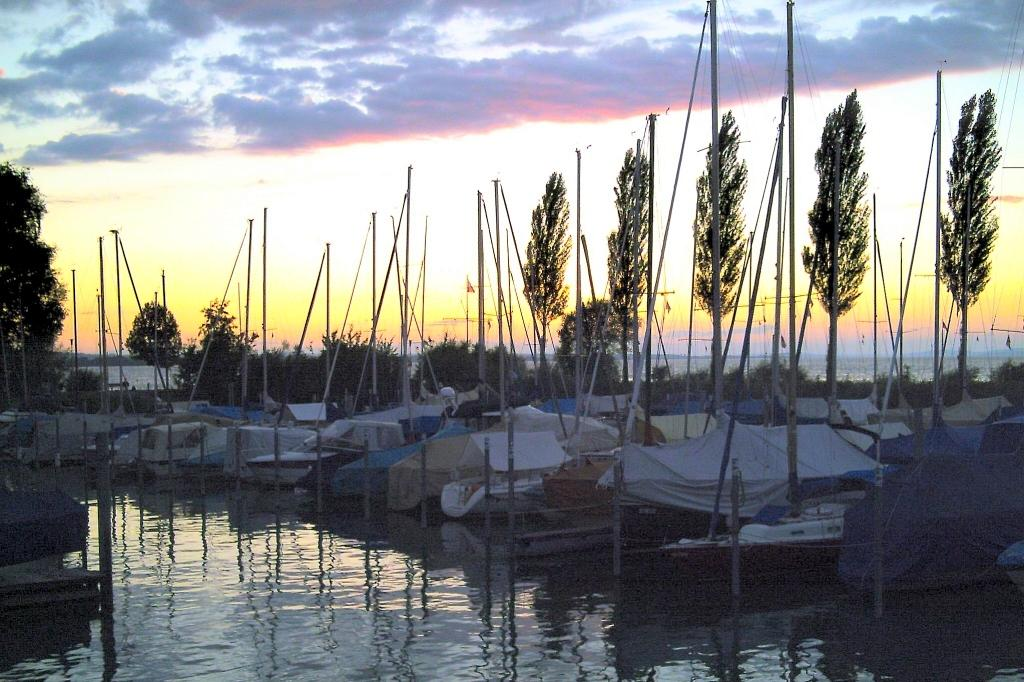What is at the bottom of the image? There is water at the bottom of the image. What can be seen floating on the water in the image? There are boats in the image. What type of vegetation is visible in the background of the image? There are trees in the background of the image. What is visible at the top of the image? The sky is visible at the top of the image. How many geese are swimming in the stomach of the image? There are no geese present in the image, and the concept of a stomach in an image is not applicable. 